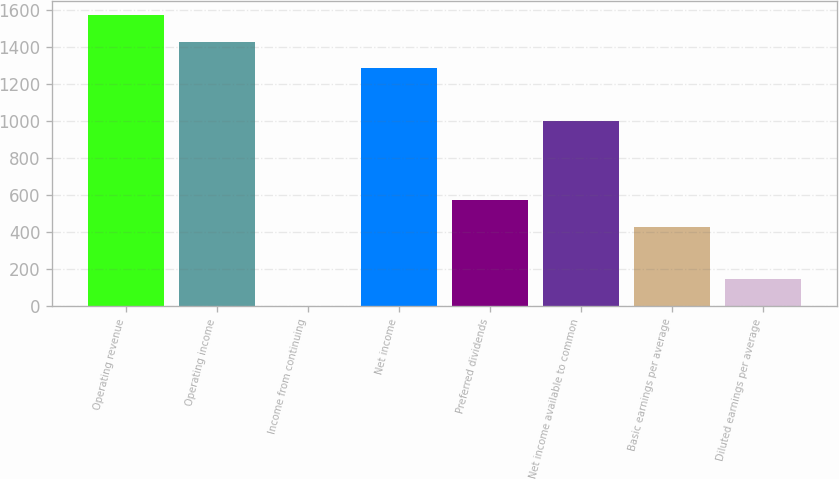<chart> <loc_0><loc_0><loc_500><loc_500><bar_chart><fcel>Operating revenue<fcel>Operating income<fcel>Income from continuing<fcel>Net income<fcel>Preferred dividends<fcel>Net income available to common<fcel>Basic earnings per average<fcel>Diluted earnings per average<nl><fcel>1570.8<fcel>1428.03<fcel>0.33<fcel>1285.26<fcel>571.41<fcel>999.72<fcel>428.64<fcel>143.1<nl></chart> 